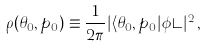<formula> <loc_0><loc_0><loc_500><loc_500>\rho ( \theta _ { 0 } , p _ { 0 } ) \equiv \frac { 1 } { 2 \pi } | \langle \theta _ { 0 } , p _ { 0 } | \phi \rangle | ^ { 2 } \, ,</formula> 